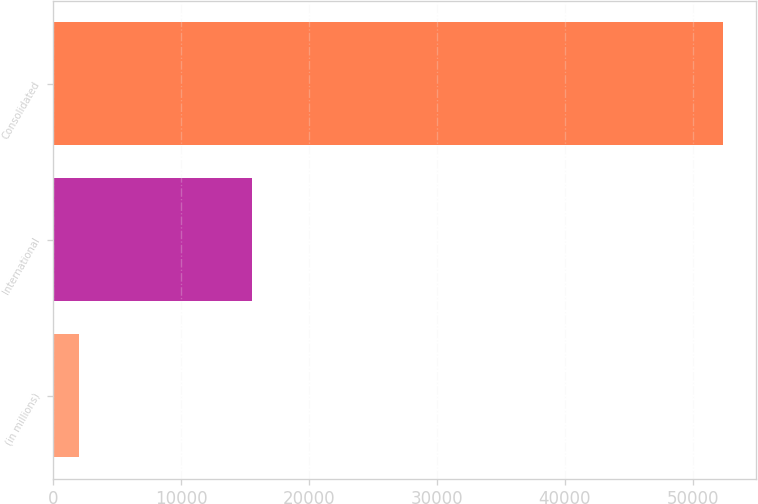Convert chart to OTSL. <chart><loc_0><loc_0><loc_500><loc_500><bar_chart><fcel>(in millions)<fcel>International<fcel>Consolidated<nl><fcel>2016<fcel>15496<fcel>52367<nl></chart> 